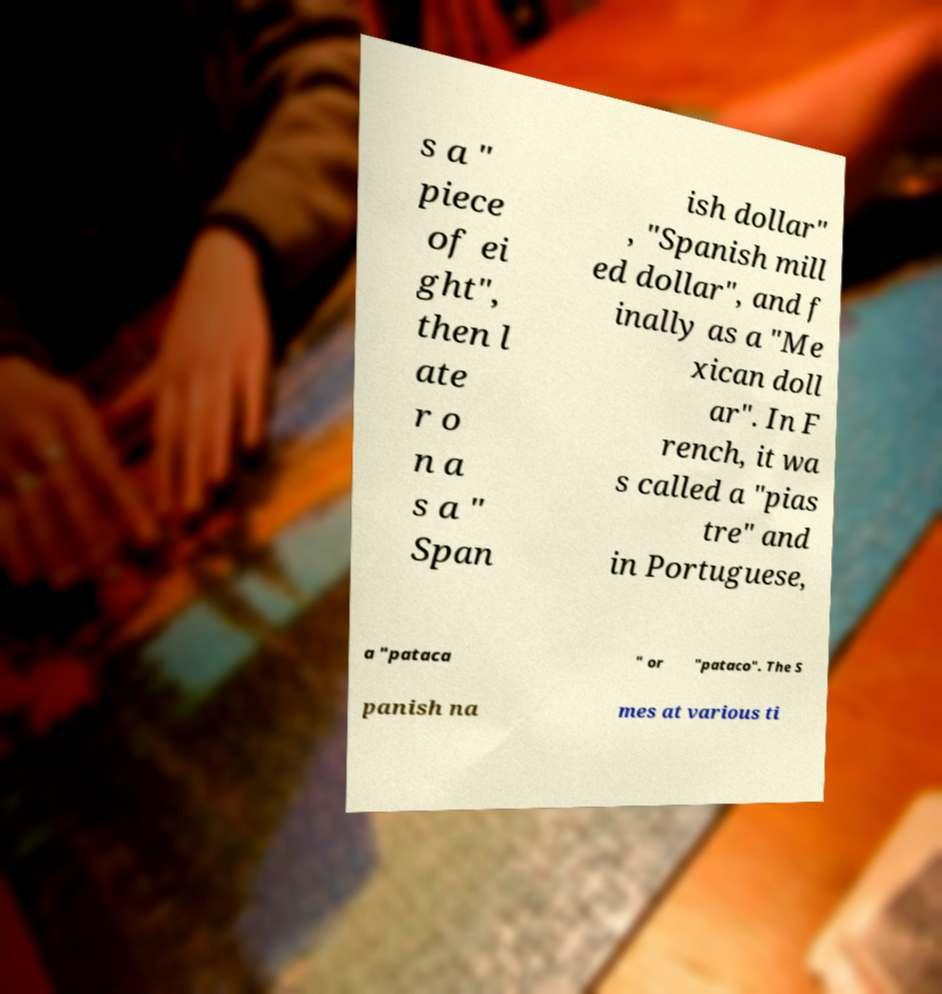I need the written content from this picture converted into text. Can you do that? s a " piece of ei ght", then l ate r o n a s a " Span ish dollar" , "Spanish mill ed dollar", and f inally as a "Me xican doll ar". In F rench, it wa s called a "pias tre" and in Portuguese, a "pataca " or "pataco". The S panish na mes at various ti 